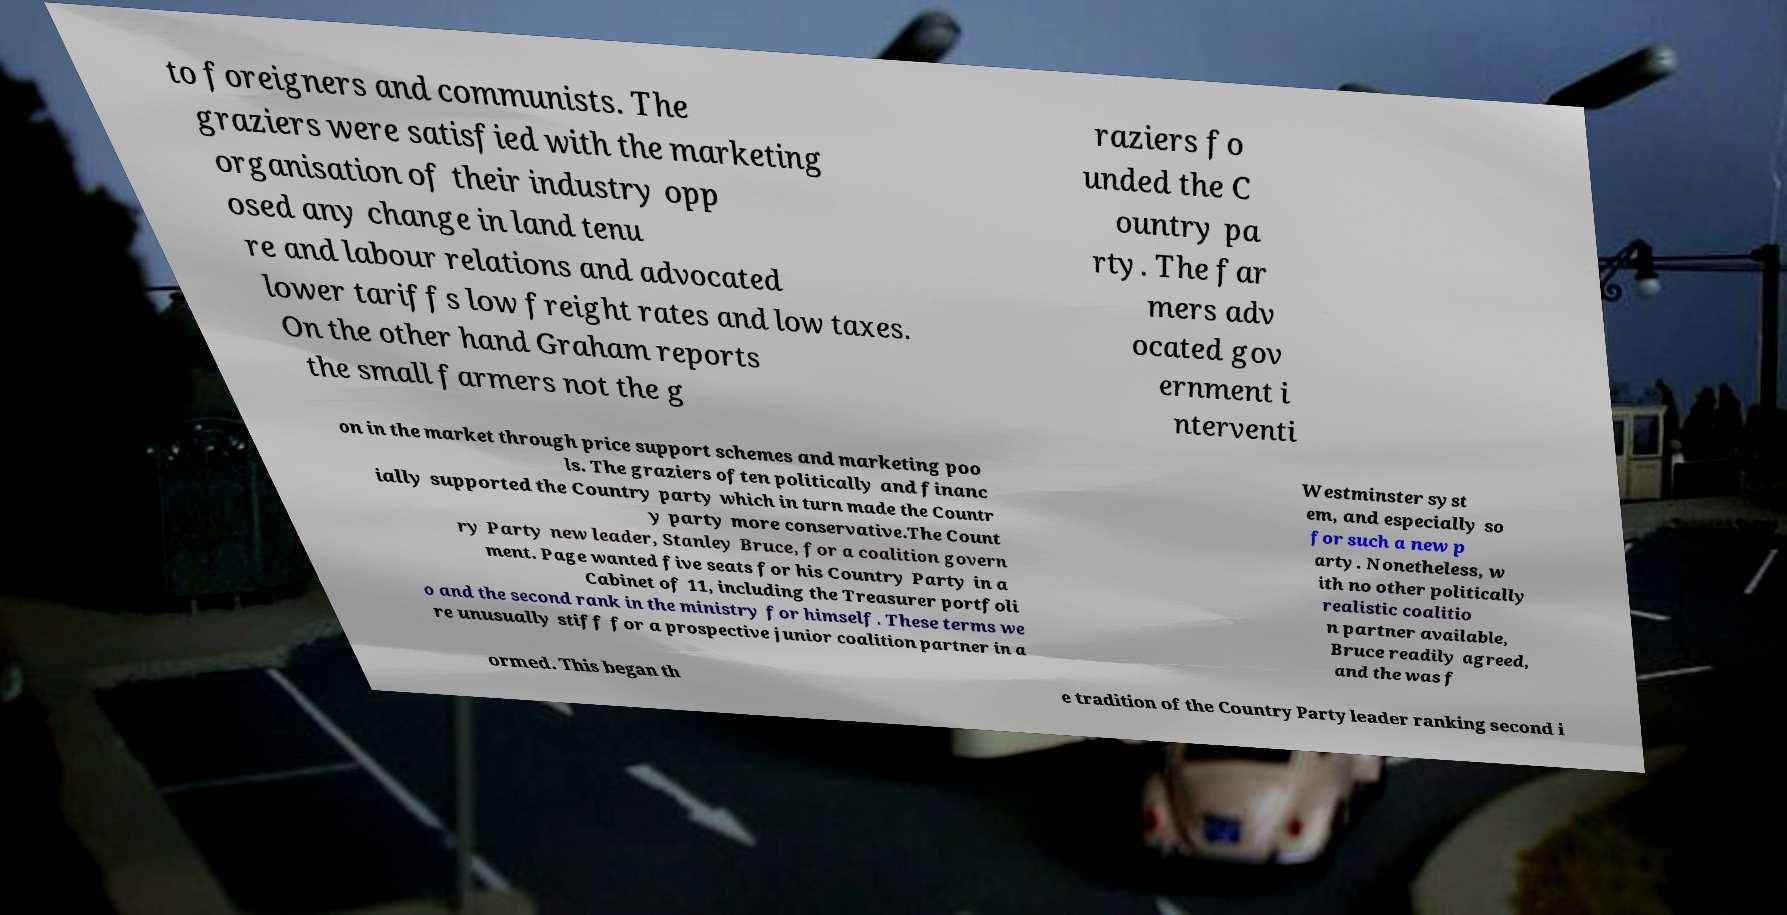For documentation purposes, I need the text within this image transcribed. Could you provide that? to foreigners and communists. The graziers were satisfied with the marketing organisation of their industry opp osed any change in land tenu re and labour relations and advocated lower tariffs low freight rates and low taxes. On the other hand Graham reports the small farmers not the g raziers fo unded the C ountry pa rty. The far mers adv ocated gov ernment i nterventi on in the market through price support schemes and marketing poo ls. The graziers often politically and financ ially supported the Country party which in turn made the Countr y party more conservative.The Count ry Party new leader, Stanley Bruce, for a coalition govern ment. Page wanted five seats for his Country Party in a Cabinet of 11, including the Treasurer portfoli o and the second rank in the ministry for himself. These terms we re unusually stiff for a prospective junior coalition partner in a Westminster syst em, and especially so for such a new p arty. Nonetheless, w ith no other politically realistic coalitio n partner available, Bruce readily agreed, and the was f ormed. This began th e tradition of the Country Party leader ranking second i 